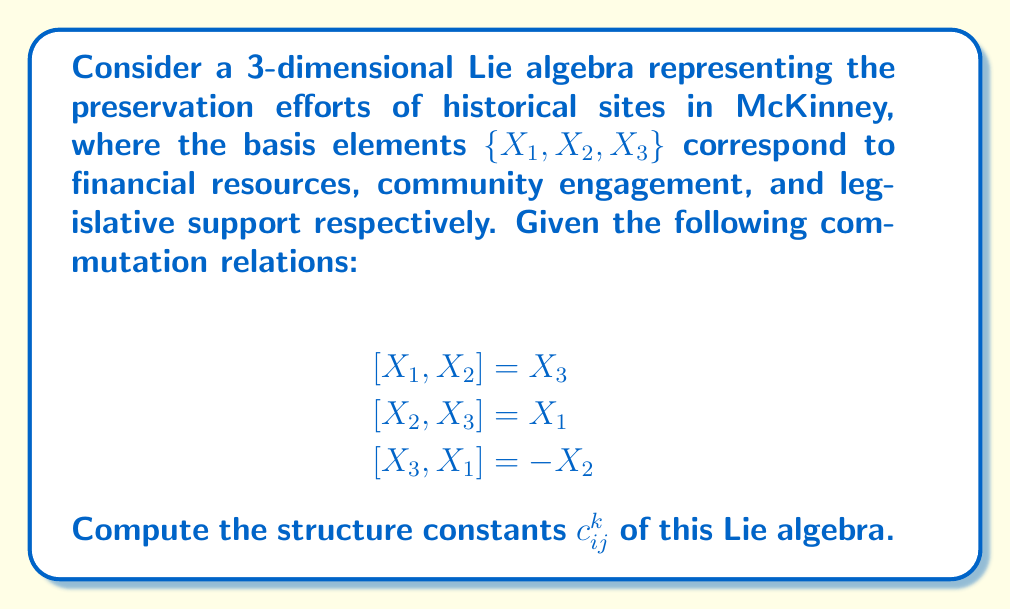Provide a solution to this math problem. To compute the structure constants of a Lie algebra, we need to express the commutation relations in terms of the structure constants using the general formula:

$$[X_i, X_j] = \sum_{k=1}^3 c_{ij}^k X_k$$

Let's analyze each commutation relation:

1. For $[X_1, X_2] = X_3$:
   This implies $c_{12}^3 = 1$, and all other $c_{12}^k = 0$ for $k \neq 3$.

2. For $[X_2, X_3] = X_1$:
   This implies $c_{23}^1 = 1$, and all other $c_{23}^k = 0$ for $k \neq 1$.

3. For $[X_3, X_1] = -X_2$:
   This implies $c_{31}^2 = -1$, and all other $c_{31}^k = 0$ for $k \neq 2$.

We also need to consider the antisymmetry property of the Lie bracket:
$$[X_i, X_j] = -[X_j, X_i]$$

This means that:
$c_{ij}^k = -c_{ji}^k$

Therefore:
$c_{21}^3 = -1$
$c_{32}^1 = -1$
$c_{13}^2 = 1$

All other structure constants are zero.
Answer: The non-zero structure constants are:

$c_{12}^3 = 1$
$c_{23}^1 = 1$
$c_{31}^2 = -1$
$c_{21}^3 = -1$
$c_{32}^1 = -1$
$c_{13}^2 = 1$

All other $c_{ij}^k = 0$. 